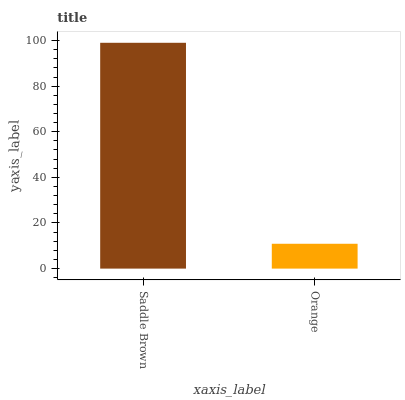Is Orange the minimum?
Answer yes or no. Yes. Is Saddle Brown the maximum?
Answer yes or no. Yes. Is Orange the maximum?
Answer yes or no. No. Is Saddle Brown greater than Orange?
Answer yes or no. Yes. Is Orange less than Saddle Brown?
Answer yes or no. Yes. Is Orange greater than Saddle Brown?
Answer yes or no. No. Is Saddle Brown less than Orange?
Answer yes or no. No. Is Saddle Brown the high median?
Answer yes or no. Yes. Is Orange the low median?
Answer yes or no. Yes. Is Orange the high median?
Answer yes or no. No. Is Saddle Brown the low median?
Answer yes or no. No. 